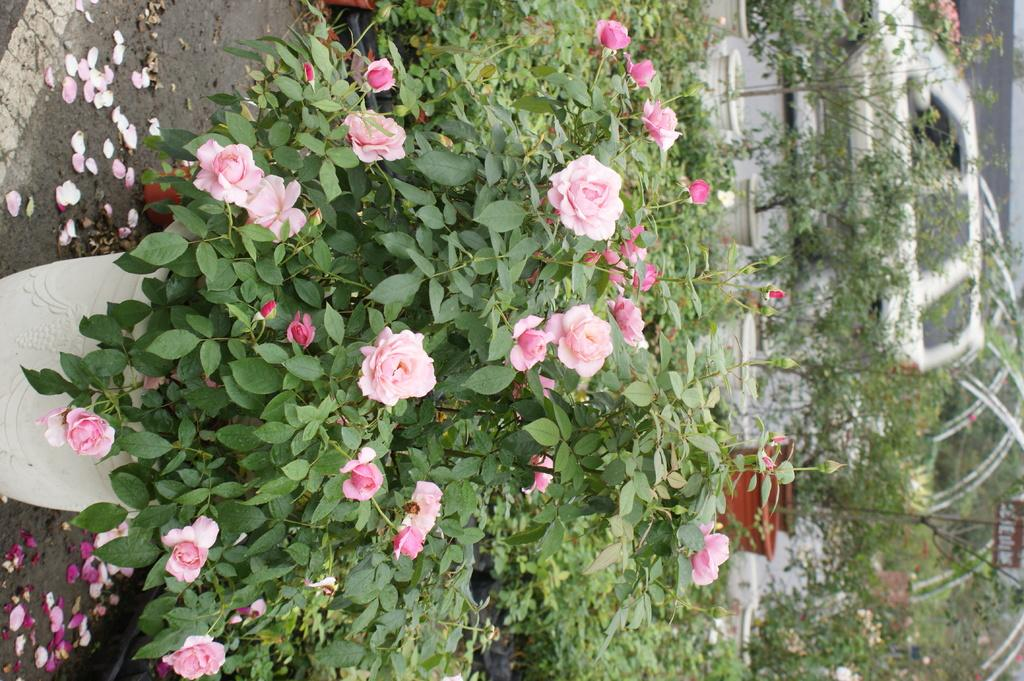What is placed on the ground in the image? There is a plant placed on the ground in the image. What else can be seen in the background of the image? There are plants and a car visible in the background of the image. What is the wall in the background of the image made of? The fact does not specify the material of the wall, so we cannot determine its composition from the given information. How many plants are visible in the image? There is one plant placed on the ground and additional plants visible in the background, so at least two plants are present in the image. What belief does the plant on the ground hold in the image? Plants do not hold beliefs, as they are living organisms and not capable of forming beliefs. 